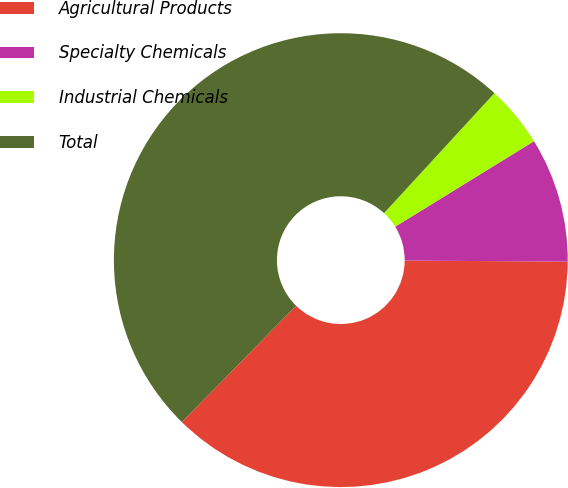Convert chart to OTSL. <chart><loc_0><loc_0><loc_500><loc_500><pie_chart><fcel>Agricultural Products<fcel>Specialty Chemicals<fcel>Industrial Chemicals<fcel>Total<nl><fcel>37.25%<fcel>8.89%<fcel>4.38%<fcel>49.49%<nl></chart> 